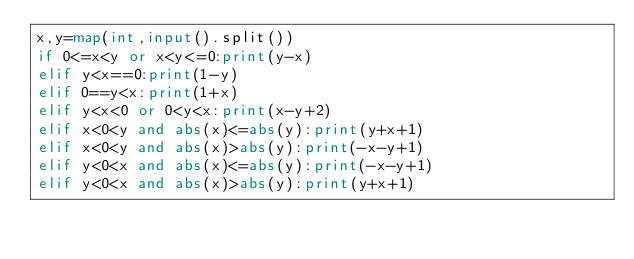<code> <loc_0><loc_0><loc_500><loc_500><_Python_>x,y=map(int,input().split())
if 0<=x<y or x<y<=0:print(y-x)
elif y<x==0:print(1-y)
elif 0==y<x:print(1+x)
elif y<x<0 or 0<y<x:print(x-y+2)
elif x<0<y and abs(x)<=abs(y):print(y+x+1)
elif x<0<y and abs(x)>abs(y):print(-x-y+1)
elif y<0<x and abs(x)<=abs(y):print(-x-y+1)
elif y<0<x and abs(x)>abs(y):print(y+x+1)</code> 